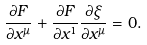<formula> <loc_0><loc_0><loc_500><loc_500>\frac { \partial F } { \partial x ^ { \mu } } + \frac { \partial F } { \partial x ^ { 1 } } \frac { \partial \xi } { \partial x ^ { \mu } } = 0 .</formula> 